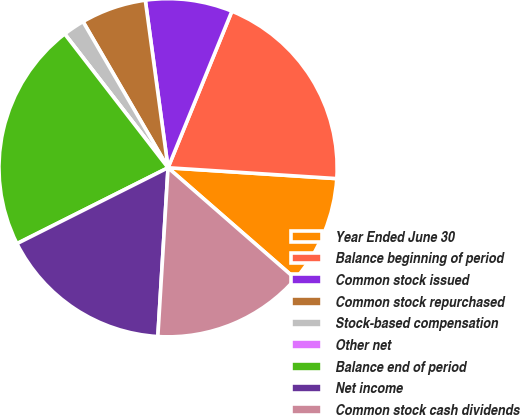Convert chart. <chart><loc_0><loc_0><loc_500><loc_500><pie_chart><fcel>Year Ended June 30<fcel>Balance beginning of period<fcel>Common stock issued<fcel>Common stock repurchased<fcel>Stock-based compensation<fcel>Other net<fcel>Balance end of period<fcel>Net income<fcel>Common stock cash dividends<nl><fcel>10.39%<fcel>19.86%<fcel>8.31%<fcel>6.24%<fcel>2.08%<fcel>0.0%<fcel>21.94%<fcel>16.63%<fcel>14.55%<nl></chart> 